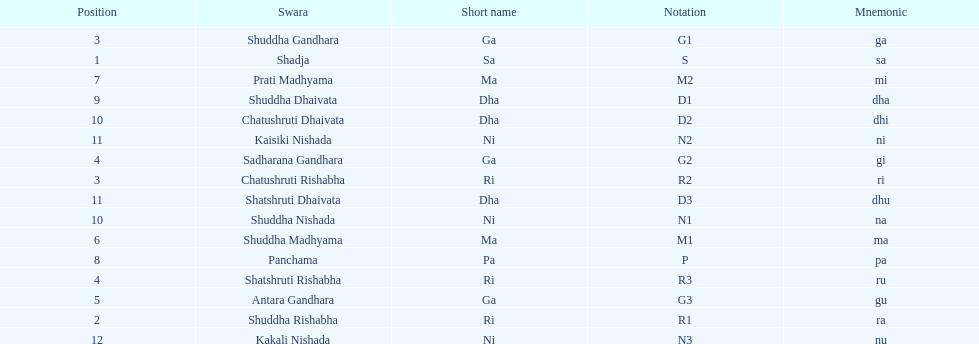On average how many of the swara have a short name that begin with d or g? 6. 